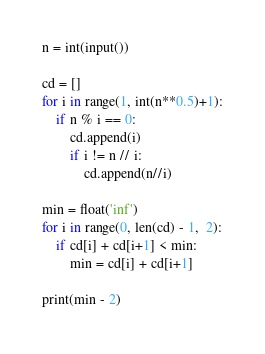Convert code to text. <code><loc_0><loc_0><loc_500><loc_500><_Python_>n = int(input())

cd = []
for i in range(1, int(n**0.5)+1):
    if n % i == 0:
        cd.append(i)
        if i != n // i:
            cd.append(n//i)

min = float('inf')
for i in range(0, len(cd) - 1,  2):
    if cd[i] + cd[i+1] < min:
        min = cd[i] + cd[i+1]

print(min - 2)
</code> 